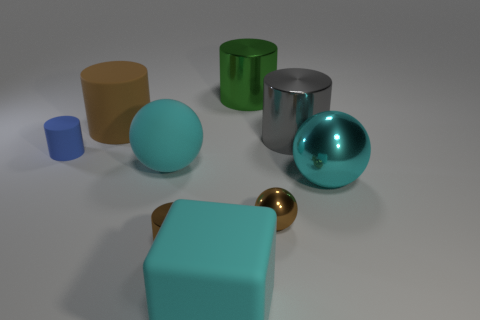Subtract all green cylinders. How many cyan spheres are left? 2 Subtract all small shiny spheres. How many spheres are left? 2 Add 1 tiny spheres. How many objects exist? 10 Subtract all green cylinders. How many cylinders are left? 4 Subtract 3 cylinders. How many cylinders are left? 2 Subtract all balls. How many objects are left? 6 Subtract all purple cylinders. Subtract all brown blocks. How many cylinders are left? 5 Add 7 small blue balls. How many small blue balls exist? 7 Subtract 0 cyan cylinders. How many objects are left? 9 Subtract all large cylinders. Subtract all big brown rubber things. How many objects are left? 5 